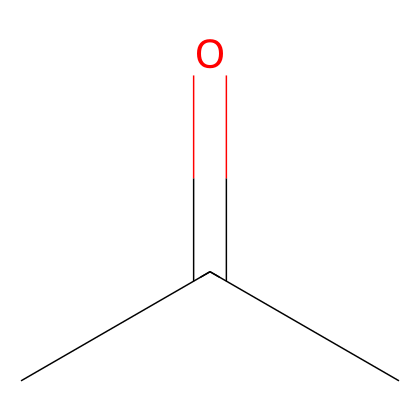What is the main functional group present in this compound? The SMILES representation shows a carbonyl group (C=O) at the middle of the structure, indicating that the compound is a ketone.
Answer: carbonyl How many carbon atoms are in acetone? The SMILES representation shows "CC(=O)C," which indicates that there are three carbon atoms in total; two are in the chain and one is part of the carbonyl group.
Answer: three What type of chemical is acetone classified as? Acetone is identified by the presence of a carbonyl group flanked by two other carbon atoms, classifying it as a ketone.
Answer: ketone How many hydrogen atoms are in this molecule? Analyzing the structure from the SMILES reveals that there are six hydrogen atoms attached to the carbon framework: two for the terminal carbon and three plus one for the central carbon.
Answer: six Which atoms are double-bonded in this molecule? In the structure, the carbonyl (C=O) indicates that the carbon atom in the center is double-bonded to an oxygen atom.
Answer: carbon and oxygen What property does the presence of a carbonyl group confer to acetone? The carbonyl group's presence gives acetone its characteristic solvent properties, contributing to its volatility and polar nature.
Answer: solvent properties 